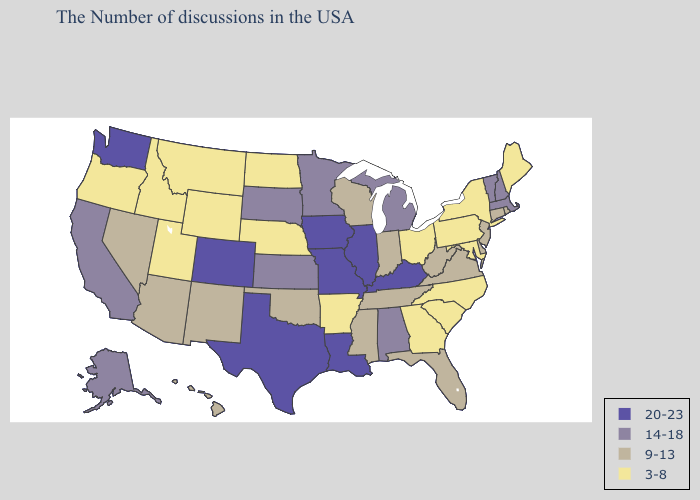Does West Virginia have a higher value than South Dakota?
Keep it brief. No. Among the states that border Washington , which have the highest value?
Concise answer only. Idaho, Oregon. What is the lowest value in states that border Indiana?
Quick response, please. 3-8. Name the states that have a value in the range 20-23?
Short answer required. Kentucky, Illinois, Louisiana, Missouri, Iowa, Texas, Colorado, Washington. Name the states that have a value in the range 20-23?
Write a very short answer. Kentucky, Illinois, Louisiana, Missouri, Iowa, Texas, Colorado, Washington. Name the states that have a value in the range 14-18?
Answer briefly. Massachusetts, New Hampshire, Vermont, Michigan, Alabama, Minnesota, Kansas, South Dakota, California, Alaska. What is the value of Kansas?
Write a very short answer. 14-18. Does Wyoming have the highest value in the USA?
Write a very short answer. No. Name the states that have a value in the range 14-18?
Write a very short answer. Massachusetts, New Hampshire, Vermont, Michigan, Alabama, Minnesota, Kansas, South Dakota, California, Alaska. Name the states that have a value in the range 14-18?
Be succinct. Massachusetts, New Hampshire, Vermont, Michigan, Alabama, Minnesota, Kansas, South Dakota, California, Alaska. What is the lowest value in the South?
Write a very short answer. 3-8. What is the highest value in the USA?
Give a very brief answer. 20-23. Does Pennsylvania have the highest value in the Northeast?
Be succinct. No. Does Oklahoma have the same value as Arizona?
Quick response, please. Yes. 